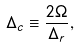Convert formula to latex. <formula><loc_0><loc_0><loc_500><loc_500>\Delta _ { c } \equiv \frac { 2 \Omega } { \Delta _ { r } } ,</formula> 